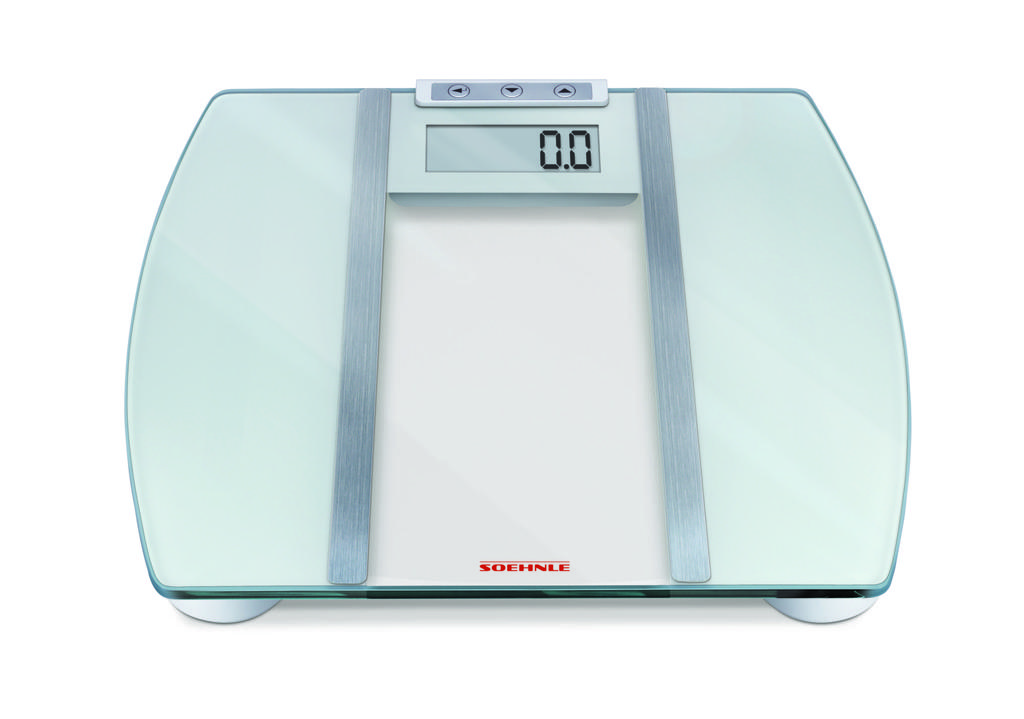How much weight is on the scale now?
Keep it short and to the point. 0.0. What is the company name that makes the scale?
Ensure brevity in your answer.  Soehnle. 